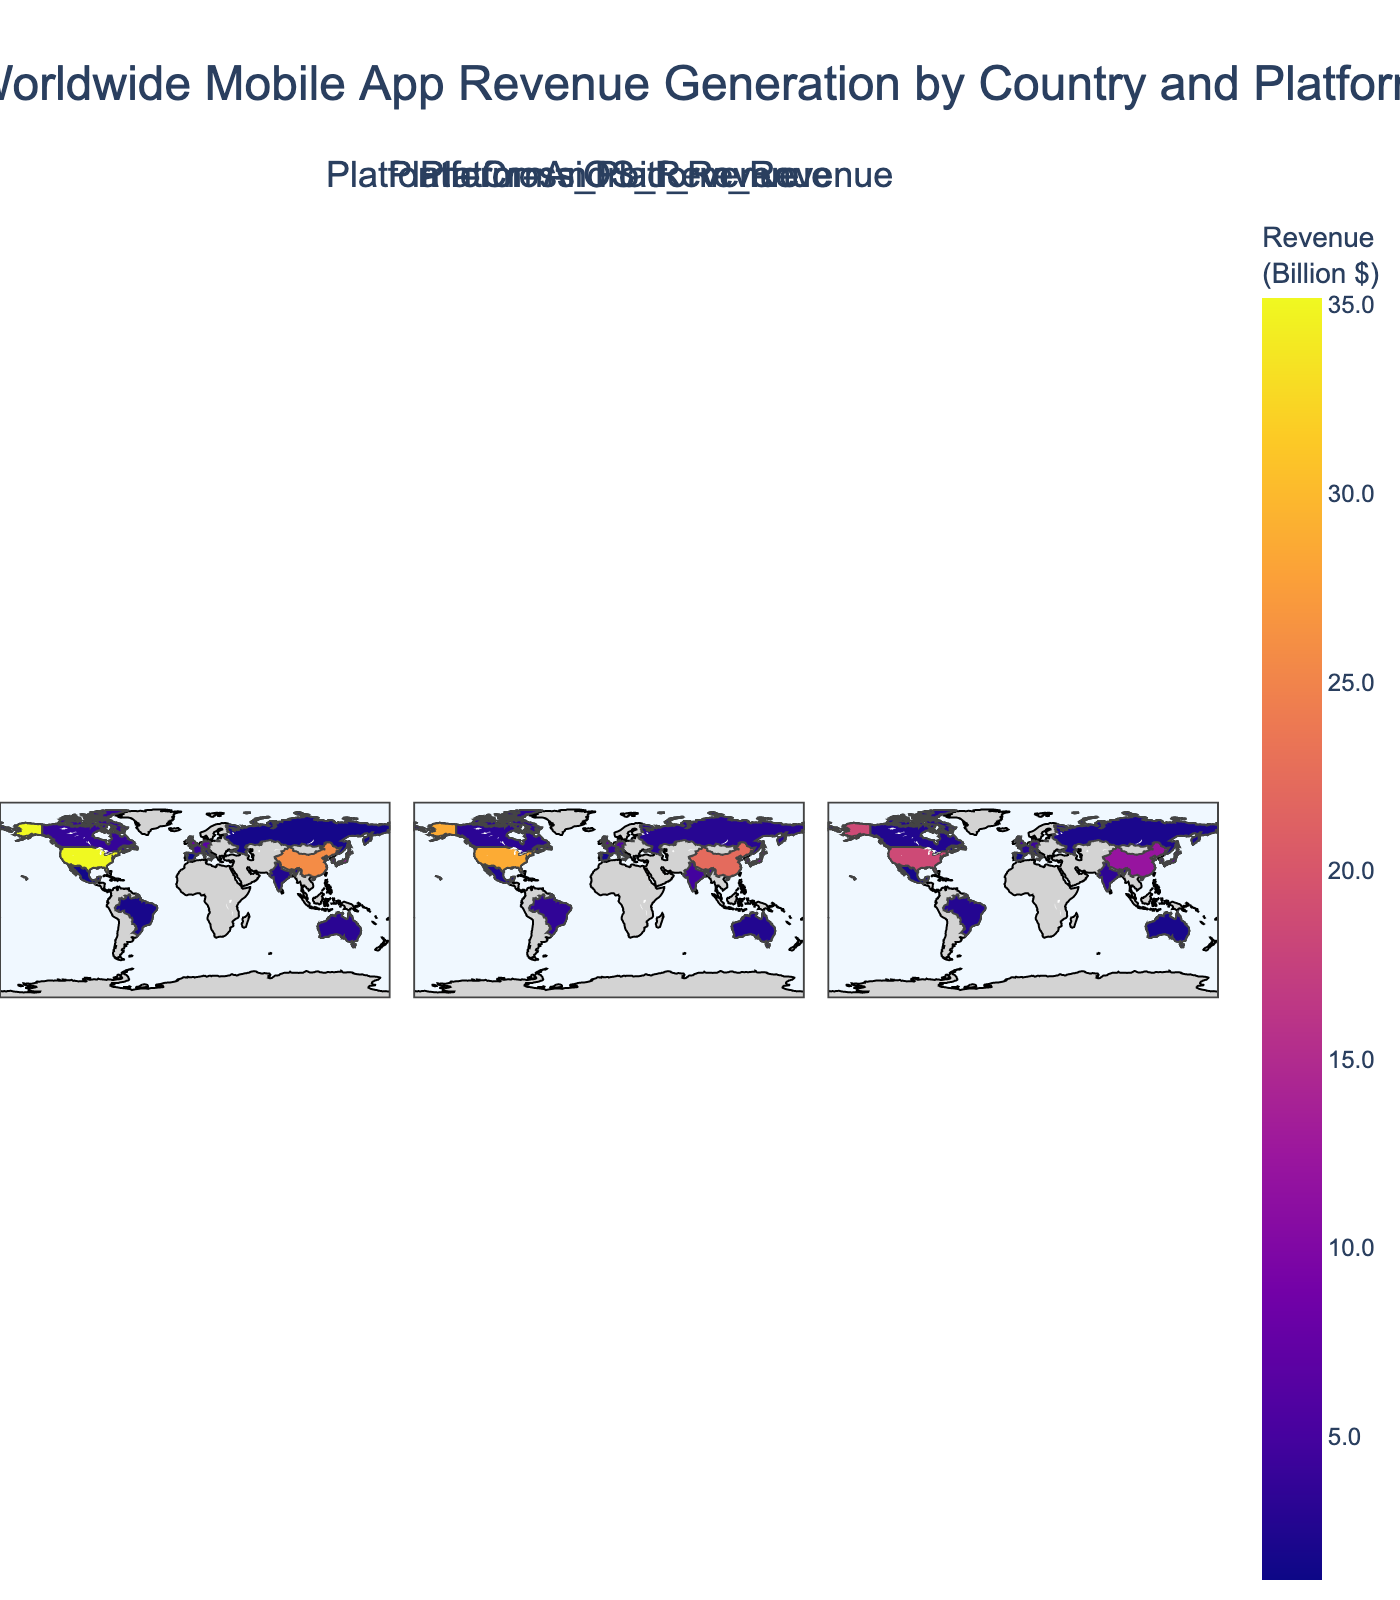What is the title of the figure? The title of the figure is typically displayed prominently at the top of the plot. It provides a summary of what the plot represents.
Answer: Worldwide Mobile App Revenue Generation by Country and Platform Which country generates the most revenue on both iOS and Android platforms? To find this information, locate the country with the highest color intensity in both the iOS and Android plot panels.
Answer: United States What is the revenue difference between iOS and Cross-Platform in Japan? Identify the revenue values for Japan in both the iOS and Cross-Platform panels, then subtract the Cross-Platform revenue from the iOS revenue. The values are 12.5 (iOS) and 7.2 (Cross-Platform). 12.5 - 7.2 = 5.3 billion dollars.
Answer: 5.3 billion dollars How many countries show higher Android revenue compared to iOS revenue? Compare the intensity of colors for both iOS and Android for each country. South Korea, India, Brazil, Russia, and Mexico show higher revenue in Android than iOS.
Answer: 5 countries What is the average revenue generated by Cross-Platform apps in the given countries? Sum all the provided Cross-Platform revenue values and divide by the number of countries. \( (18.5 + 12.1 + 7.2 + 5.1 + 4.3 + 3.8 + 2.9 + 2.5 + 2.0 + 3.3 + 2.7 + 2.1 + 1.8 + 1.5 + 1.3) = 71.2 \), and the number of countries is 15. So, 71.2 / 15 ≈ 4.75 billion dollars.
Answer: 4.75 billion dollars Which platforms generate more revenue in the United Kingdom: iOS or Android? Compare the revenue values for the United Kingdom in the iOS and Android platform panels. The values are 8.3 (iOS) and 6.9 (Android). Since 8.3 is greater than 6.9, iOS generates more revenue.
Answer: iOS Name the countries where Cross-Platform revenue is less than 3 billion dollars. Identify the countries in the Cross-Platform panel where the revenue values are less than 3. Those countries are France, Canada, Australia, Italy, Spain.
Answer: France, Canada, Australia, Italy, Spain Which country has the closest revenue distribution among iOS, Android, and Cross-Platform? Compare the revenue values across all three platforms for all countries. Canada has values of 3.8 (iOS), 3.2 (Android), and 2.5 (Cross-Platform), which are relatively close to each other.
Answer: Canada 